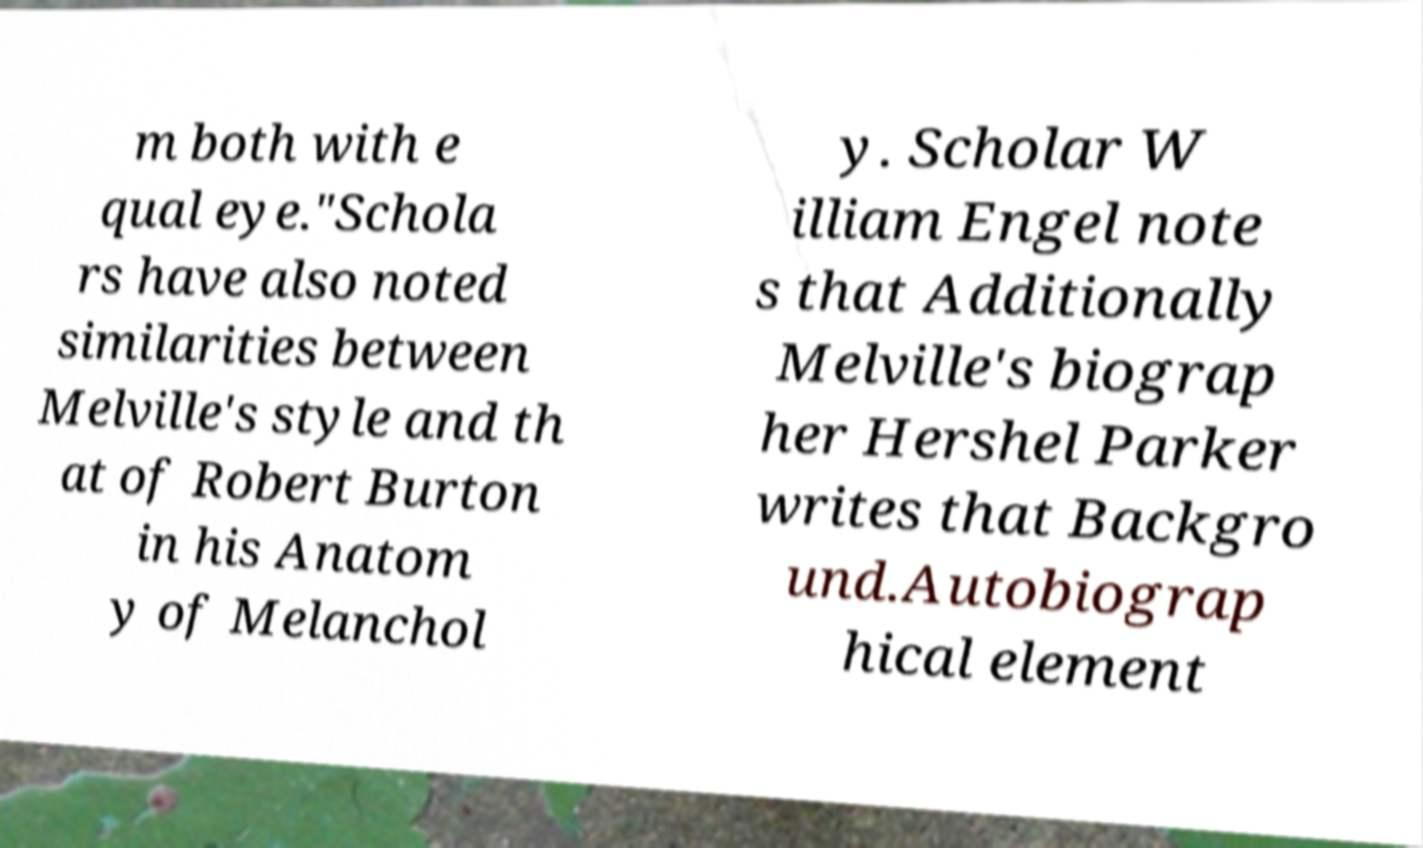There's text embedded in this image that I need extracted. Can you transcribe it verbatim? m both with e qual eye."Schola rs have also noted similarities between Melville's style and th at of Robert Burton in his Anatom y of Melanchol y. Scholar W illiam Engel note s that Additionally Melville's biograp her Hershel Parker writes that Backgro und.Autobiograp hical element 